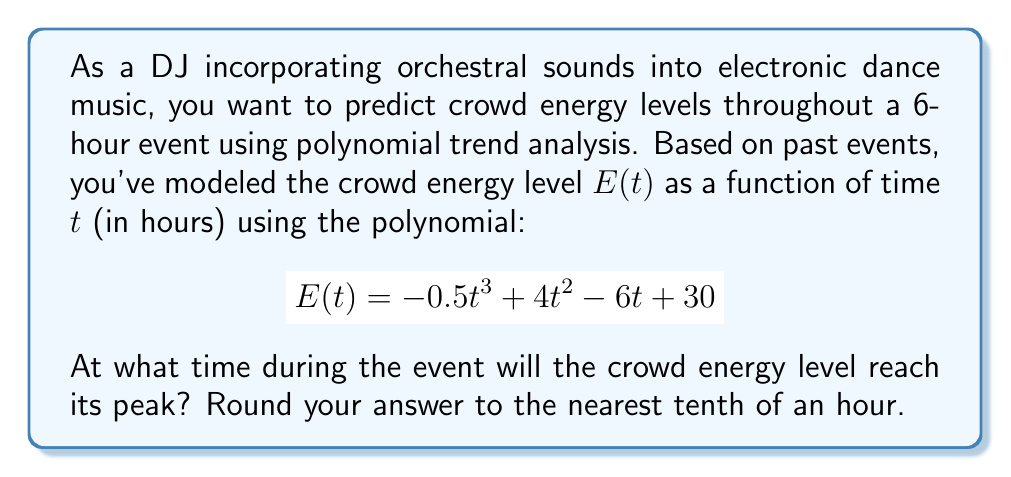Help me with this question. To find the time when the crowd energy level reaches its peak, we need to follow these steps:

1) The maximum point of the function occurs where its first derivative equals zero. Let's find the first derivative of $E(t)$:

   $$E'(t) = -1.5t^2 + 8t - 6$$

2) Set the first derivative equal to zero and solve for $t$:

   $$-1.5t^2 + 8t - 6 = 0$$

3) This is a quadratic equation. We can solve it using the quadratic formula:

   $$t = \frac{-b \pm \sqrt{b^2 - 4ac}}{2a}$$

   where $a = -1.5$, $b = 8$, and $c = -6$

4) Substituting these values:

   $$t = \frac{-8 \pm \sqrt{8^2 - 4(-1.5)(-6)}}{2(-1.5)}$$
   
   $$t = \frac{-8 \pm \sqrt{64 - 36}}{-3}$$
   
   $$t = \frac{-8 \pm \sqrt{28}}{-3}$$
   
   $$t = \frac{-8 \pm 2\sqrt{7}}{-3}$$

5) This gives us two solutions:

   $$t_1 = \frac{-8 + 2\sqrt{7}}{-3} \approx 4.1$$
   
   $$t_2 = \frac{-8 - 2\sqrt{7}}{-3} \approx 1.2$$

6) To determine which of these is the maximum (rather than the minimum), we can check the second derivative:

   $$E''(t) = -3t + 8$$

   At $t \approx 4.1$, $E''(4.1) < 0$, indicating this is indeed a maximum.

7) Rounding to the nearest tenth of an hour, we get 4.1 hours.
Answer: 4.1 hours 